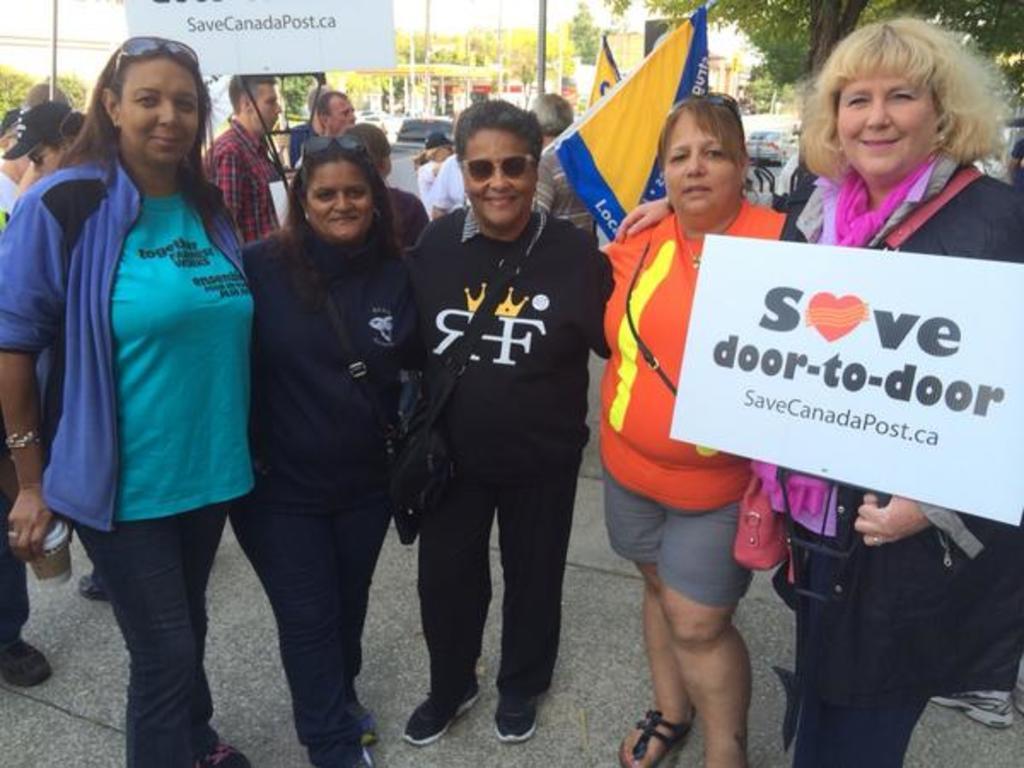Could you give a brief overview of what you see in this image? There are five persons in different color dresses, smiling and standing on a footpath. One of them is holding a placard. In the background, there are persons, Some of them are holding flags and one is holding a placard, there are trees, poles, vehicles on the road and there is sky. 